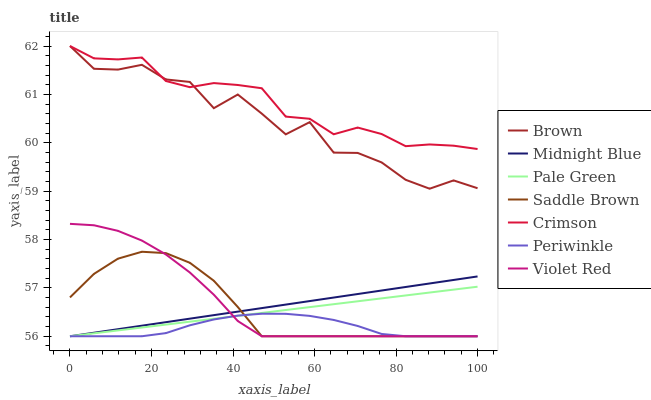Does Periwinkle have the minimum area under the curve?
Answer yes or no. Yes. Does Crimson have the maximum area under the curve?
Answer yes or no. Yes. Does Violet Red have the minimum area under the curve?
Answer yes or no. No. Does Violet Red have the maximum area under the curve?
Answer yes or no. No. Is Midnight Blue the smoothest?
Answer yes or no. Yes. Is Brown the roughest?
Answer yes or no. Yes. Is Violet Red the smoothest?
Answer yes or no. No. Is Violet Red the roughest?
Answer yes or no. No. Does Violet Red have the lowest value?
Answer yes or no. Yes. Does Crimson have the lowest value?
Answer yes or no. No. Does Crimson have the highest value?
Answer yes or no. Yes. Does Violet Red have the highest value?
Answer yes or no. No. Is Violet Red less than Brown?
Answer yes or no. Yes. Is Brown greater than Midnight Blue?
Answer yes or no. Yes. Does Violet Red intersect Midnight Blue?
Answer yes or no. Yes. Is Violet Red less than Midnight Blue?
Answer yes or no. No. Is Violet Red greater than Midnight Blue?
Answer yes or no. No. Does Violet Red intersect Brown?
Answer yes or no. No. 